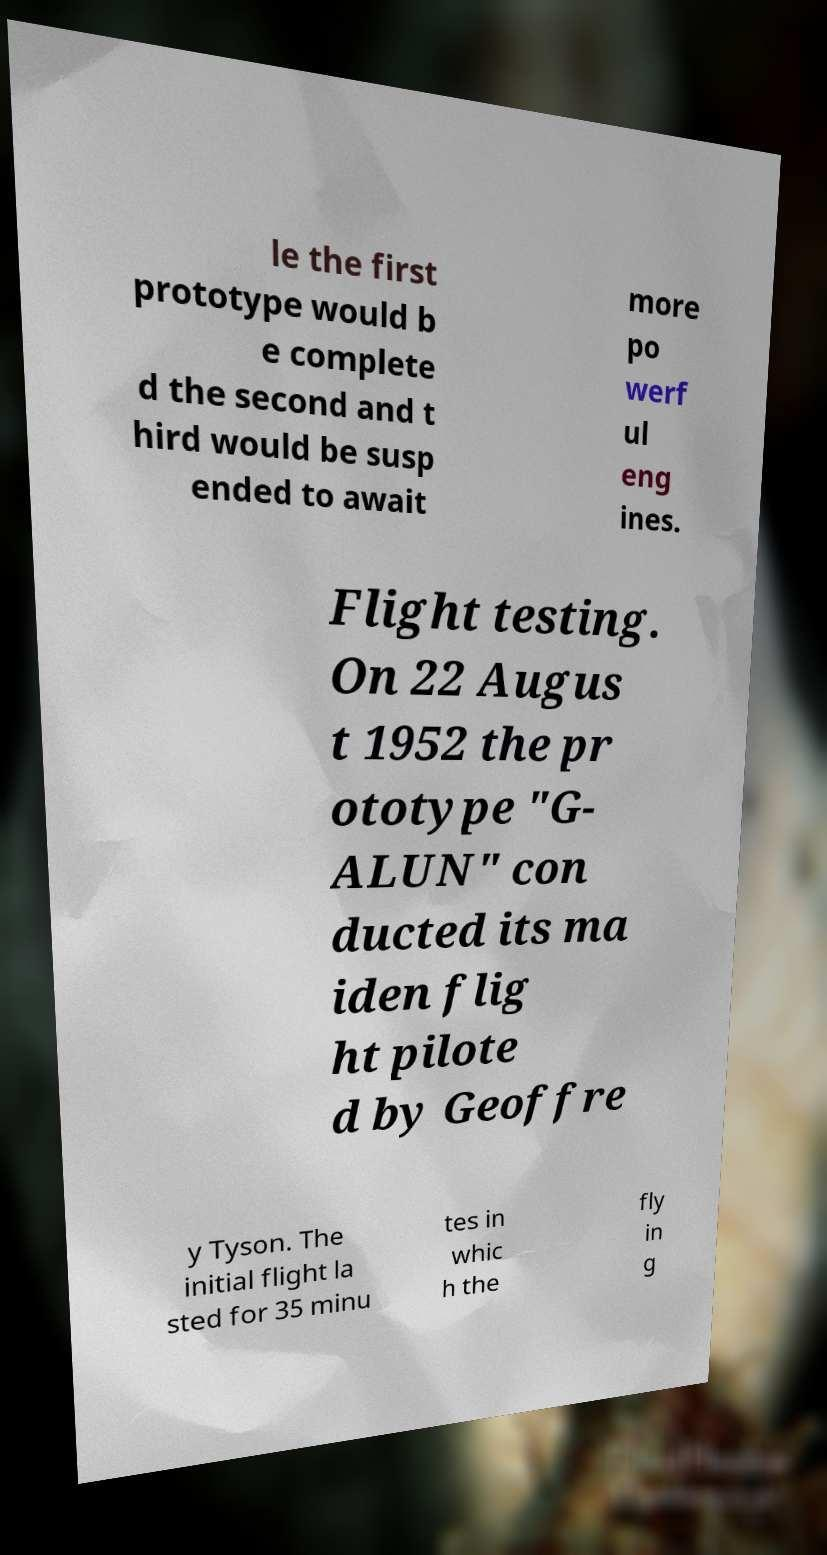Please read and relay the text visible in this image. What does it say? le the first prototype would b e complete d the second and t hird would be susp ended to await more po werf ul eng ines. Flight testing. On 22 Augus t 1952 the pr ototype "G- ALUN" con ducted its ma iden flig ht pilote d by Geoffre y Tyson. The initial flight la sted for 35 minu tes in whic h the fly in g 